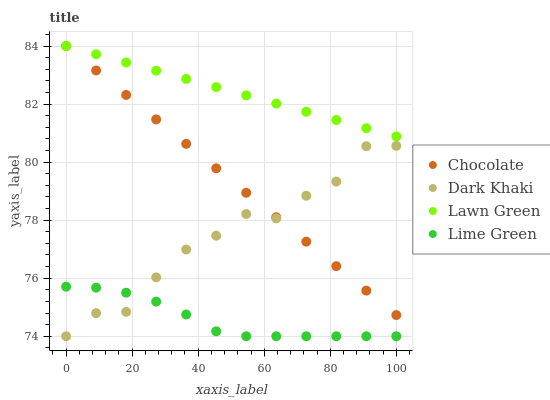Does Lime Green have the minimum area under the curve?
Answer yes or no. Yes. Does Lawn Green have the maximum area under the curve?
Answer yes or no. Yes. Does Lawn Green have the minimum area under the curve?
Answer yes or no. No. Does Lime Green have the maximum area under the curve?
Answer yes or no. No. Is Lawn Green the smoothest?
Answer yes or no. Yes. Is Dark Khaki the roughest?
Answer yes or no. Yes. Is Lime Green the smoothest?
Answer yes or no. No. Is Lime Green the roughest?
Answer yes or no. No. Does Dark Khaki have the lowest value?
Answer yes or no. Yes. Does Lawn Green have the lowest value?
Answer yes or no. No. Does Chocolate have the highest value?
Answer yes or no. Yes. Does Lime Green have the highest value?
Answer yes or no. No. Is Lime Green less than Chocolate?
Answer yes or no. Yes. Is Chocolate greater than Lime Green?
Answer yes or no. Yes. Does Dark Khaki intersect Chocolate?
Answer yes or no. Yes. Is Dark Khaki less than Chocolate?
Answer yes or no. No. Is Dark Khaki greater than Chocolate?
Answer yes or no. No. Does Lime Green intersect Chocolate?
Answer yes or no. No. 